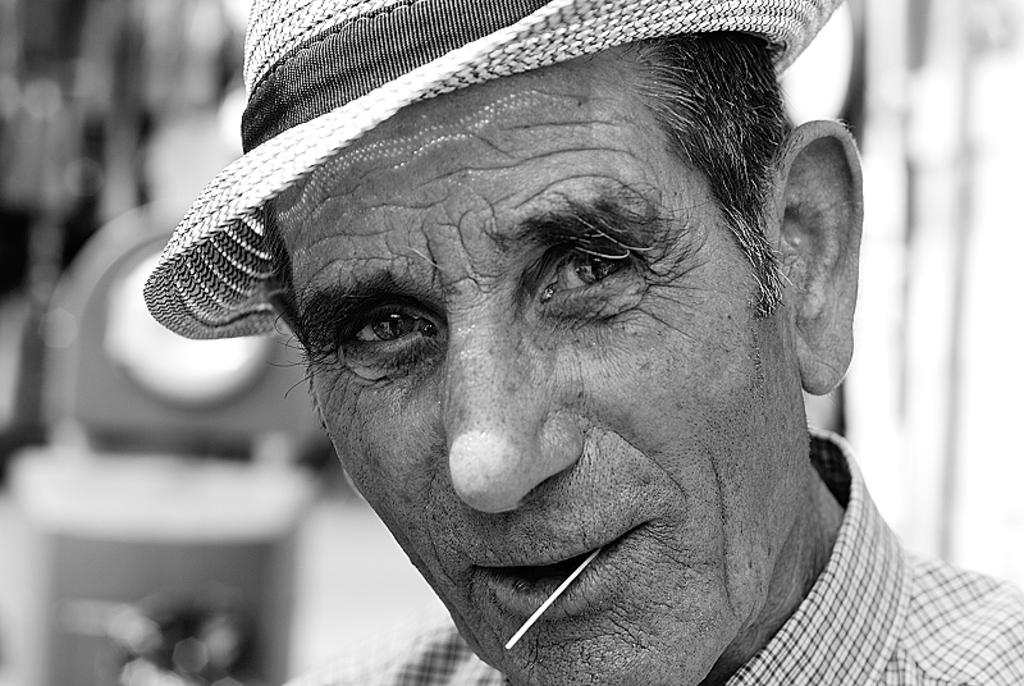Who is present in the image? There is a man in the image. What is the man wearing on his head? The man is wearing a hat. What object is the man holding in the image? The man is holding a stick. Can you describe the background of the image? The background of the image is blurry. What type of goldfish can be seen swimming in the image? There are no goldfish present in the image; it features a man wearing a hat and holding a stick with a blurry background. 